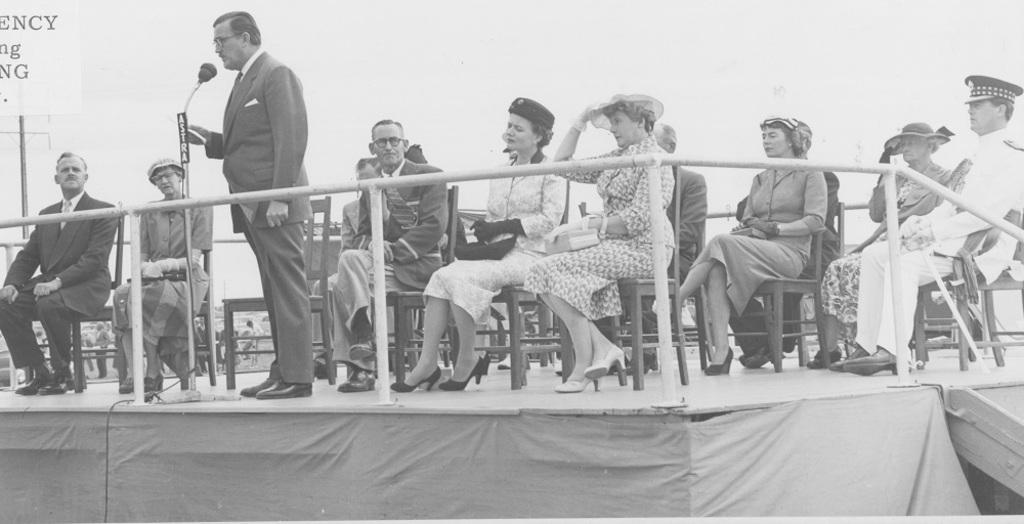In one or two sentences, can you explain what this image depicts? In this image there is a person standing is speaking in a mic, behind the person there are a few people seated on chairs on the stage. 